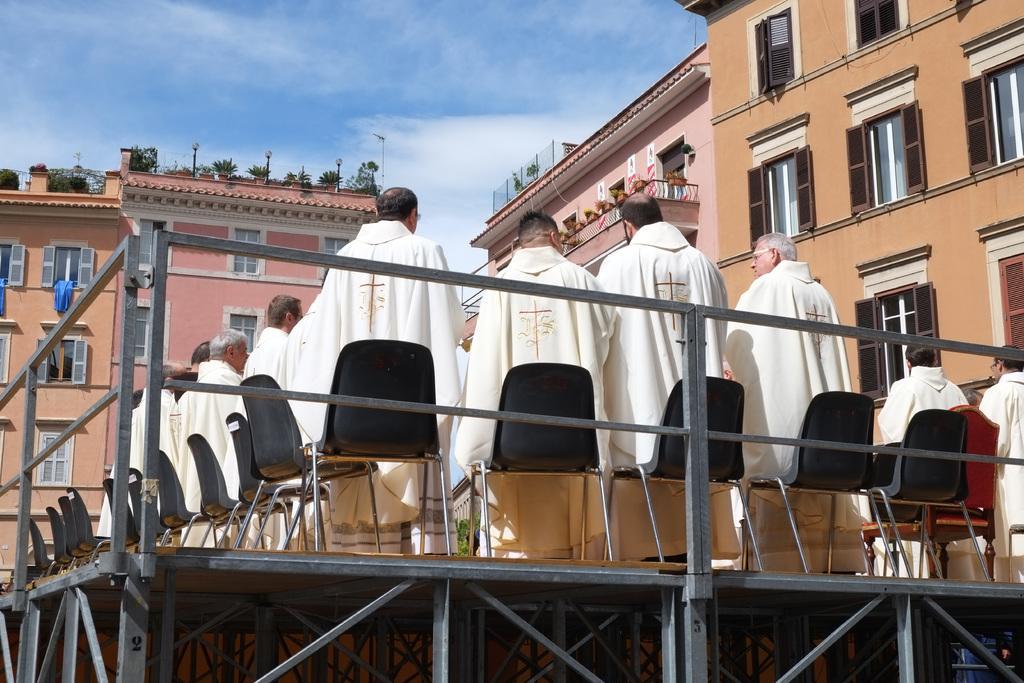Could you give a brief overview of what you see in this image? There are group of persons standing besides the chairs on the stage. All the men are turning backwards and all of them are wearing white dresses. In the background there are some buildings, plants and a blue sky. 